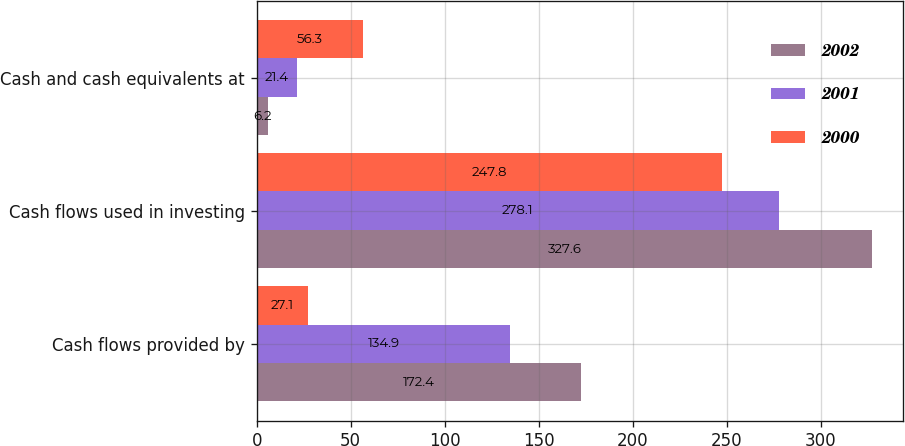<chart> <loc_0><loc_0><loc_500><loc_500><stacked_bar_chart><ecel><fcel>Cash flows provided by<fcel>Cash flows used in investing<fcel>Cash and cash equivalents at<nl><fcel>2002<fcel>172.4<fcel>327.6<fcel>6.2<nl><fcel>2001<fcel>134.9<fcel>278.1<fcel>21.4<nl><fcel>2000<fcel>27.1<fcel>247.8<fcel>56.3<nl></chart> 